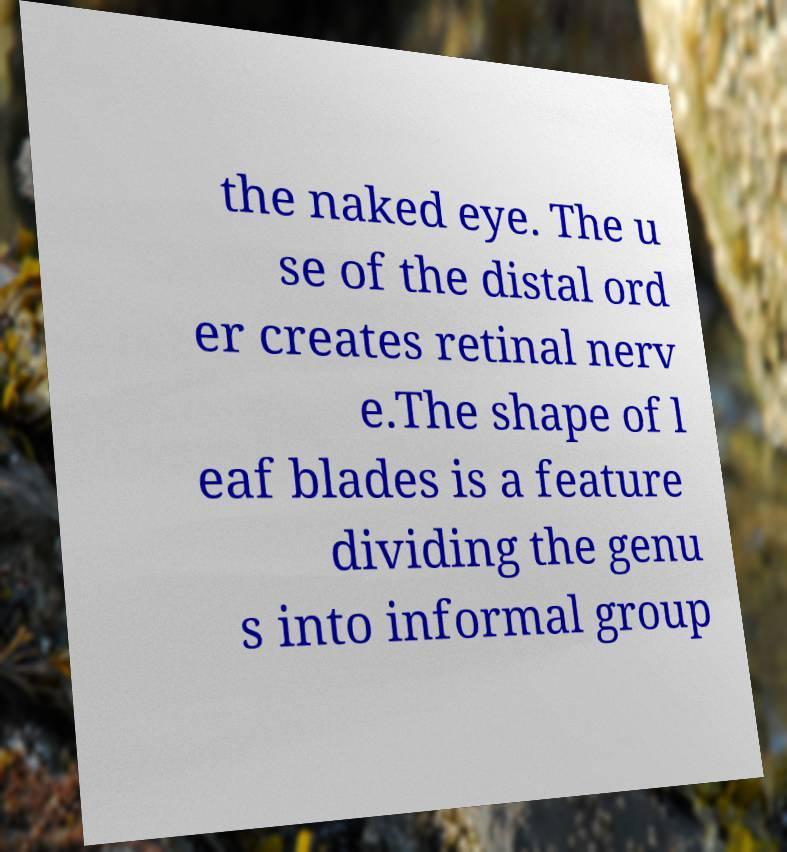There's text embedded in this image that I need extracted. Can you transcribe it verbatim? the naked eye. The u se of the distal ord er creates retinal nerv e.The shape of l eaf blades is a feature dividing the genu s into informal group 